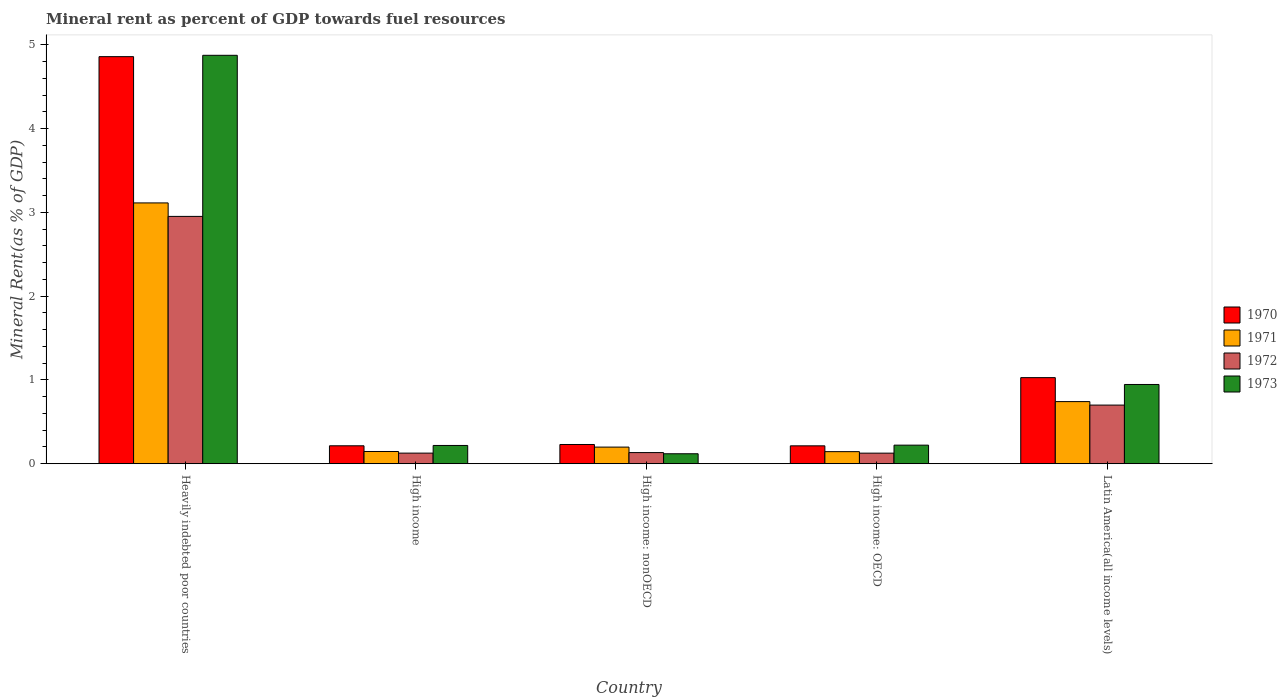How many different coloured bars are there?
Your answer should be compact. 4. What is the label of the 4th group of bars from the left?
Make the answer very short. High income: OECD. What is the mineral rent in 1973 in High income: OECD?
Offer a very short reply. 0.22. Across all countries, what is the maximum mineral rent in 1970?
Your response must be concise. 4.86. Across all countries, what is the minimum mineral rent in 1970?
Offer a terse response. 0.21. In which country was the mineral rent in 1970 maximum?
Ensure brevity in your answer.  Heavily indebted poor countries. In which country was the mineral rent in 1973 minimum?
Your answer should be very brief. High income: nonOECD. What is the total mineral rent in 1970 in the graph?
Your answer should be very brief. 6.54. What is the difference between the mineral rent in 1972 in High income and that in High income: OECD?
Your response must be concise. 0. What is the difference between the mineral rent in 1970 in Latin America(all income levels) and the mineral rent in 1973 in Heavily indebted poor countries?
Make the answer very short. -3.85. What is the average mineral rent in 1970 per country?
Your response must be concise. 1.31. What is the difference between the mineral rent of/in 1972 and mineral rent of/in 1970 in High income?
Your response must be concise. -0.09. In how many countries, is the mineral rent in 1972 greater than 2.2 %?
Your answer should be very brief. 1. What is the ratio of the mineral rent in 1972 in Heavily indebted poor countries to that in High income?
Make the answer very short. 23.3. What is the difference between the highest and the second highest mineral rent in 1973?
Your answer should be compact. -3.93. What is the difference between the highest and the lowest mineral rent in 1972?
Provide a succinct answer. 2.83. Is the sum of the mineral rent in 1971 in High income and High income: nonOECD greater than the maximum mineral rent in 1973 across all countries?
Give a very brief answer. No. Is it the case that in every country, the sum of the mineral rent in 1972 and mineral rent in 1970 is greater than the sum of mineral rent in 1971 and mineral rent in 1973?
Provide a succinct answer. No. What does the 3rd bar from the left in High income: OECD represents?
Give a very brief answer. 1972. What does the 1st bar from the right in Latin America(all income levels) represents?
Provide a succinct answer. 1973. How many bars are there?
Provide a succinct answer. 20. What is the difference between two consecutive major ticks on the Y-axis?
Make the answer very short. 1. Are the values on the major ticks of Y-axis written in scientific E-notation?
Ensure brevity in your answer.  No. Where does the legend appear in the graph?
Offer a terse response. Center right. What is the title of the graph?
Give a very brief answer. Mineral rent as percent of GDP towards fuel resources. Does "1986" appear as one of the legend labels in the graph?
Your answer should be very brief. No. What is the label or title of the X-axis?
Offer a very short reply. Country. What is the label or title of the Y-axis?
Keep it short and to the point. Mineral Rent(as % of GDP). What is the Mineral Rent(as % of GDP) in 1970 in Heavily indebted poor countries?
Provide a short and direct response. 4.86. What is the Mineral Rent(as % of GDP) in 1971 in Heavily indebted poor countries?
Keep it short and to the point. 3.11. What is the Mineral Rent(as % of GDP) of 1972 in Heavily indebted poor countries?
Keep it short and to the point. 2.95. What is the Mineral Rent(as % of GDP) of 1973 in Heavily indebted poor countries?
Offer a terse response. 4.87. What is the Mineral Rent(as % of GDP) of 1970 in High income?
Make the answer very short. 0.21. What is the Mineral Rent(as % of GDP) of 1971 in High income?
Your answer should be compact. 0.15. What is the Mineral Rent(as % of GDP) of 1972 in High income?
Your response must be concise. 0.13. What is the Mineral Rent(as % of GDP) of 1973 in High income?
Make the answer very short. 0.22. What is the Mineral Rent(as % of GDP) of 1970 in High income: nonOECD?
Offer a very short reply. 0.23. What is the Mineral Rent(as % of GDP) in 1971 in High income: nonOECD?
Provide a succinct answer. 0.2. What is the Mineral Rent(as % of GDP) in 1972 in High income: nonOECD?
Make the answer very short. 0.13. What is the Mineral Rent(as % of GDP) in 1973 in High income: nonOECD?
Your response must be concise. 0.12. What is the Mineral Rent(as % of GDP) in 1970 in High income: OECD?
Offer a very short reply. 0.21. What is the Mineral Rent(as % of GDP) of 1971 in High income: OECD?
Your response must be concise. 0.14. What is the Mineral Rent(as % of GDP) of 1972 in High income: OECD?
Keep it short and to the point. 0.13. What is the Mineral Rent(as % of GDP) of 1973 in High income: OECD?
Your response must be concise. 0.22. What is the Mineral Rent(as % of GDP) in 1970 in Latin America(all income levels)?
Your response must be concise. 1.03. What is the Mineral Rent(as % of GDP) of 1971 in Latin America(all income levels)?
Your answer should be compact. 0.74. What is the Mineral Rent(as % of GDP) of 1972 in Latin America(all income levels)?
Your answer should be compact. 0.7. What is the Mineral Rent(as % of GDP) in 1973 in Latin America(all income levels)?
Offer a very short reply. 0.95. Across all countries, what is the maximum Mineral Rent(as % of GDP) in 1970?
Offer a very short reply. 4.86. Across all countries, what is the maximum Mineral Rent(as % of GDP) in 1971?
Give a very brief answer. 3.11. Across all countries, what is the maximum Mineral Rent(as % of GDP) in 1972?
Give a very brief answer. 2.95. Across all countries, what is the maximum Mineral Rent(as % of GDP) of 1973?
Provide a short and direct response. 4.87. Across all countries, what is the minimum Mineral Rent(as % of GDP) of 1970?
Provide a short and direct response. 0.21. Across all countries, what is the minimum Mineral Rent(as % of GDP) of 1971?
Provide a succinct answer. 0.14. Across all countries, what is the minimum Mineral Rent(as % of GDP) in 1972?
Provide a succinct answer. 0.13. Across all countries, what is the minimum Mineral Rent(as % of GDP) in 1973?
Offer a terse response. 0.12. What is the total Mineral Rent(as % of GDP) of 1970 in the graph?
Provide a short and direct response. 6.54. What is the total Mineral Rent(as % of GDP) in 1971 in the graph?
Provide a short and direct response. 4.34. What is the total Mineral Rent(as % of GDP) in 1972 in the graph?
Ensure brevity in your answer.  4.04. What is the total Mineral Rent(as % of GDP) of 1973 in the graph?
Your answer should be compact. 6.38. What is the difference between the Mineral Rent(as % of GDP) in 1970 in Heavily indebted poor countries and that in High income?
Your answer should be compact. 4.64. What is the difference between the Mineral Rent(as % of GDP) in 1971 in Heavily indebted poor countries and that in High income?
Ensure brevity in your answer.  2.97. What is the difference between the Mineral Rent(as % of GDP) in 1972 in Heavily indebted poor countries and that in High income?
Provide a short and direct response. 2.82. What is the difference between the Mineral Rent(as % of GDP) in 1973 in Heavily indebted poor countries and that in High income?
Offer a very short reply. 4.66. What is the difference between the Mineral Rent(as % of GDP) in 1970 in Heavily indebted poor countries and that in High income: nonOECD?
Give a very brief answer. 4.63. What is the difference between the Mineral Rent(as % of GDP) of 1971 in Heavily indebted poor countries and that in High income: nonOECD?
Your response must be concise. 2.91. What is the difference between the Mineral Rent(as % of GDP) of 1972 in Heavily indebted poor countries and that in High income: nonOECD?
Offer a very short reply. 2.82. What is the difference between the Mineral Rent(as % of GDP) of 1973 in Heavily indebted poor countries and that in High income: nonOECD?
Keep it short and to the point. 4.75. What is the difference between the Mineral Rent(as % of GDP) in 1970 in Heavily indebted poor countries and that in High income: OECD?
Offer a very short reply. 4.64. What is the difference between the Mineral Rent(as % of GDP) in 1971 in Heavily indebted poor countries and that in High income: OECD?
Your answer should be very brief. 2.97. What is the difference between the Mineral Rent(as % of GDP) in 1972 in Heavily indebted poor countries and that in High income: OECD?
Make the answer very short. 2.83. What is the difference between the Mineral Rent(as % of GDP) in 1973 in Heavily indebted poor countries and that in High income: OECD?
Ensure brevity in your answer.  4.65. What is the difference between the Mineral Rent(as % of GDP) of 1970 in Heavily indebted poor countries and that in Latin America(all income levels)?
Your answer should be very brief. 3.83. What is the difference between the Mineral Rent(as % of GDP) of 1971 in Heavily indebted poor countries and that in Latin America(all income levels)?
Provide a succinct answer. 2.37. What is the difference between the Mineral Rent(as % of GDP) of 1972 in Heavily indebted poor countries and that in Latin America(all income levels)?
Make the answer very short. 2.25. What is the difference between the Mineral Rent(as % of GDP) in 1973 in Heavily indebted poor countries and that in Latin America(all income levels)?
Your answer should be compact. 3.93. What is the difference between the Mineral Rent(as % of GDP) in 1970 in High income and that in High income: nonOECD?
Ensure brevity in your answer.  -0.02. What is the difference between the Mineral Rent(as % of GDP) of 1971 in High income and that in High income: nonOECD?
Make the answer very short. -0.05. What is the difference between the Mineral Rent(as % of GDP) of 1972 in High income and that in High income: nonOECD?
Make the answer very short. -0.01. What is the difference between the Mineral Rent(as % of GDP) in 1973 in High income and that in High income: nonOECD?
Your answer should be compact. 0.1. What is the difference between the Mineral Rent(as % of GDP) in 1970 in High income and that in High income: OECD?
Provide a succinct answer. 0. What is the difference between the Mineral Rent(as % of GDP) in 1971 in High income and that in High income: OECD?
Give a very brief answer. 0. What is the difference between the Mineral Rent(as % of GDP) in 1972 in High income and that in High income: OECD?
Your answer should be very brief. 0. What is the difference between the Mineral Rent(as % of GDP) in 1973 in High income and that in High income: OECD?
Provide a succinct answer. -0. What is the difference between the Mineral Rent(as % of GDP) of 1970 in High income and that in Latin America(all income levels)?
Keep it short and to the point. -0.81. What is the difference between the Mineral Rent(as % of GDP) in 1971 in High income and that in Latin America(all income levels)?
Provide a short and direct response. -0.6. What is the difference between the Mineral Rent(as % of GDP) of 1972 in High income and that in Latin America(all income levels)?
Make the answer very short. -0.57. What is the difference between the Mineral Rent(as % of GDP) of 1973 in High income and that in Latin America(all income levels)?
Offer a very short reply. -0.73. What is the difference between the Mineral Rent(as % of GDP) in 1970 in High income: nonOECD and that in High income: OECD?
Your answer should be very brief. 0.02. What is the difference between the Mineral Rent(as % of GDP) in 1971 in High income: nonOECD and that in High income: OECD?
Your response must be concise. 0.05. What is the difference between the Mineral Rent(as % of GDP) of 1972 in High income: nonOECD and that in High income: OECD?
Your answer should be compact. 0.01. What is the difference between the Mineral Rent(as % of GDP) of 1973 in High income: nonOECD and that in High income: OECD?
Offer a very short reply. -0.1. What is the difference between the Mineral Rent(as % of GDP) in 1970 in High income: nonOECD and that in Latin America(all income levels)?
Offer a very short reply. -0.8. What is the difference between the Mineral Rent(as % of GDP) in 1971 in High income: nonOECD and that in Latin America(all income levels)?
Keep it short and to the point. -0.54. What is the difference between the Mineral Rent(as % of GDP) of 1972 in High income: nonOECD and that in Latin America(all income levels)?
Make the answer very short. -0.57. What is the difference between the Mineral Rent(as % of GDP) of 1973 in High income: nonOECD and that in Latin America(all income levels)?
Ensure brevity in your answer.  -0.83. What is the difference between the Mineral Rent(as % of GDP) of 1970 in High income: OECD and that in Latin America(all income levels)?
Your answer should be compact. -0.81. What is the difference between the Mineral Rent(as % of GDP) of 1971 in High income: OECD and that in Latin America(all income levels)?
Provide a succinct answer. -0.6. What is the difference between the Mineral Rent(as % of GDP) of 1972 in High income: OECD and that in Latin America(all income levels)?
Provide a short and direct response. -0.57. What is the difference between the Mineral Rent(as % of GDP) of 1973 in High income: OECD and that in Latin America(all income levels)?
Provide a succinct answer. -0.72. What is the difference between the Mineral Rent(as % of GDP) of 1970 in Heavily indebted poor countries and the Mineral Rent(as % of GDP) of 1971 in High income?
Give a very brief answer. 4.71. What is the difference between the Mineral Rent(as % of GDP) of 1970 in Heavily indebted poor countries and the Mineral Rent(as % of GDP) of 1972 in High income?
Your answer should be compact. 4.73. What is the difference between the Mineral Rent(as % of GDP) of 1970 in Heavily indebted poor countries and the Mineral Rent(as % of GDP) of 1973 in High income?
Offer a terse response. 4.64. What is the difference between the Mineral Rent(as % of GDP) in 1971 in Heavily indebted poor countries and the Mineral Rent(as % of GDP) in 1972 in High income?
Ensure brevity in your answer.  2.99. What is the difference between the Mineral Rent(as % of GDP) in 1971 in Heavily indebted poor countries and the Mineral Rent(as % of GDP) in 1973 in High income?
Make the answer very short. 2.89. What is the difference between the Mineral Rent(as % of GDP) in 1972 in Heavily indebted poor countries and the Mineral Rent(as % of GDP) in 1973 in High income?
Offer a terse response. 2.73. What is the difference between the Mineral Rent(as % of GDP) of 1970 in Heavily indebted poor countries and the Mineral Rent(as % of GDP) of 1971 in High income: nonOECD?
Your answer should be very brief. 4.66. What is the difference between the Mineral Rent(as % of GDP) of 1970 in Heavily indebted poor countries and the Mineral Rent(as % of GDP) of 1972 in High income: nonOECD?
Offer a terse response. 4.72. What is the difference between the Mineral Rent(as % of GDP) of 1970 in Heavily indebted poor countries and the Mineral Rent(as % of GDP) of 1973 in High income: nonOECD?
Offer a very short reply. 4.74. What is the difference between the Mineral Rent(as % of GDP) in 1971 in Heavily indebted poor countries and the Mineral Rent(as % of GDP) in 1972 in High income: nonOECD?
Offer a terse response. 2.98. What is the difference between the Mineral Rent(as % of GDP) of 1971 in Heavily indebted poor countries and the Mineral Rent(as % of GDP) of 1973 in High income: nonOECD?
Ensure brevity in your answer.  2.99. What is the difference between the Mineral Rent(as % of GDP) of 1972 in Heavily indebted poor countries and the Mineral Rent(as % of GDP) of 1973 in High income: nonOECD?
Make the answer very short. 2.83. What is the difference between the Mineral Rent(as % of GDP) in 1970 in Heavily indebted poor countries and the Mineral Rent(as % of GDP) in 1971 in High income: OECD?
Offer a terse response. 4.71. What is the difference between the Mineral Rent(as % of GDP) of 1970 in Heavily indebted poor countries and the Mineral Rent(as % of GDP) of 1972 in High income: OECD?
Give a very brief answer. 4.73. What is the difference between the Mineral Rent(as % of GDP) in 1970 in Heavily indebted poor countries and the Mineral Rent(as % of GDP) in 1973 in High income: OECD?
Offer a terse response. 4.64. What is the difference between the Mineral Rent(as % of GDP) in 1971 in Heavily indebted poor countries and the Mineral Rent(as % of GDP) in 1972 in High income: OECD?
Provide a succinct answer. 2.99. What is the difference between the Mineral Rent(as % of GDP) in 1971 in Heavily indebted poor countries and the Mineral Rent(as % of GDP) in 1973 in High income: OECD?
Provide a short and direct response. 2.89. What is the difference between the Mineral Rent(as % of GDP) in 1972 in Heavily indebted poor countries and the Mineral Rent(as % of GDP) in 1973 in High income: OECD?
Offer a terse response. 2.73. What is the difference between the Mineral Rent(as % of GDP) of 1970 in Heavily indebted poor countries and the Mineral Rent(as % of GDP) of 1971 in Latin America(all income levels)?
Offer a very short reply. 4.12. What is the difference between the Mineral Rent(as % of GDP) in 1970 in Heavily indebted poor countries and the Mineral Rent(as % of GDP) in 1972 in Latin America(all income levels)?
Your response must be concise. 4.16. What is the difference between the Mineral Rent(as % of GDP) in 1970 in Heavily indebted poor countries and the Mineral Rent(as % of GDP) in 1973 in Latin America(all income levels)?
Your response must be concise. 3.91. What is the difference between the Mineral Rent(as % of GDP) in 1971 in Heavily indebted poor countries and the Mineral Rent(as % of GDP) in 1972 in Latin America(all income levels)?
Ensure brevity in your answer.  2.41. What is the difference between the Mineral Rent(as % of GDP) in 1971 in Heavily indebted poor countries and the Mineral Rent(as % of GDP) in 1973 in Latin America(all income levels)?
Give a very brief answer. 2.17. What is the difference between the Mineral Rent(as % of GDP) in 1972 in Heavily indebted poor countries and the Mineral Rent(as % of GDP) in 1973 in Latin America(all income levels)?
Provide a short and direct response. 2.01. What is the difference between the Mineral Rent(as % of GDP) of 1970 in High income and the Mineral Rent(as % of GDP) of 1971 in High income: nonOECD?
Keep it short and to the point. 0.02. What is the difference between the Mineral Rent(as % of GDP) of 1970 in High income and the Mineral Rent(as % of GDP) of 1972 in High income: nonOECD?
Your answer should be compact. 0.08. What is the difference between the Mineral Rent(as % of GDP) of 1970 in High income and the Mineral Rent(as % of GDP) of 1973 in High income: nonOECD?
Offer a terse response. 0.1. What is the difference between the Mineral Rent(as % of GDP) of 1971 in High income and the Mineral Rent(as % of GDP) of 1972 in High income: nonOECD?
Ensure brevity in your answer.  0.01. What is the difference between the Mineral Rent(as % of GDP) of 1971 in High income and the Mineral Rent(as % of GDP) of 1973 in High income: nonOECD?
Your answer should be compact. 0.03. What is the difference between the Mineral Rent(as % of GDP) of 1972 in High income and the Mineral Rent(as % of GDP) of 1973 in High income: nonOECD?
Provide a short and direct response. 0.01. What is the difference between the Mineral Rent(as % of GDP) of 1970 in High income and the Mineral Rent(as % of GDP) of 1971 in High income: OECD?
Offer a terse response. 0.07. What is the difference between the Mineral Rent(as % of GDP) in 1970 in High income and the Mineral Rent(as % of GDP) in 1972 in High income: OECD?
Ensure brevity in your answer.  0.09. What is the difference between the Mineral Rent(as % of GDP) of 1970 in High income and the Mineral Rent(as % of GDP) of 1973 in High income: OECD?
Your response must be concise. -0.01. What is the difference between the Mineral Rent(as % of GDP) in 1971 in High income and the Mineral Rent(as % of GDP) in 1972 in High income: OECD?
Ensure brevity in your answer.  0.02. What is the difference between the Mineral Rent(as % of GDP) of 1971 in High income and the Mineral Rent(as % of GDP) of 1973 in High income: OECD?
Provide a succinct answer. -0.08. What is the difference between the Mineral Rent(as % of GDP) in 1972 in High income and the Mineral Rent(as % of GDP) in 1973 in High income: OECD?
Your answer should be very brief. -0.1. What is the difference between the Mineral Rent(as % of GDP) in 1970 in High income and the Mineral Rent(as % of GDP) in 1971 in Latin America(all income levels)?
Keep it short and to the point. -0.53. What is the difference between the Mineral Rent(as % of GDP) of 1970 in High income and the Mineral Rent(as % of GDP) of 1972 in Latin America(all income levels)?
Your response must be concise. -0.49. What is the difference between the Mineral Rent(as % of GDP) of 1970 in High income and the Mineral Rent(as % of GDP) of 1973 in Latin America(all income levels)?
Keep it short and to the point. -0.73. What is the difference between the Mineral Rent(as % of GDP) of 1971 in High income and the Mineral Rent(as % of GDP) of 1972 in Latin America(all income levels)?
Offer a very short reply. -0.55. What is the difference between the Mineral Rent(as % of GDP) of 1971 in High income and the Mineral Rent(as % of GDP) of 1973 in Latin America(all income levels)?
Ensure brevity in your answer.  -0.8. What is the difference between the Mineral Rent(as % of GDP) of 1972 in High income and the Mineral Rent(as % of GDP) of 1973 in Latin America(all income levels)?
Give a very brief answer. -0.82. What is the difference between the Mineral Rent(as % of GDP) of 1970 in High income: nonOECD and the Mineral Rent(as % of GDP) of 1971 in High income: OECD?
Ensure brevity in your answer.  0.09. What is the difference between the Mineral Rent(as % of GDP) of 1970 in High income: nonOECD and the Mineral Rent(as % of GDP) of 1972 in High income: OECD?
Give a very brief answer. 0.1. What is the difference between the Mineral Rent(as % of GDP) of 1970 in High income: nonOECD and the Mineral Rent(as % of GDP) of 1973 in High income: OECD?
Provide a short and direct response. 0.01. What is the difference between the Mineral Rent(as % of GDP) of 1971 in High income: nonOECD and the Mineral Rent(as % of GDP) of 1972 in High income: OECD?
Ensure brevity in your answer.  0.07. What is the difference between the Mineral Rent(as % of GDP) in 1971 in High income: nonOECD and the Mineral Rent(as % of GDP) in 1973 in High income: OECD?
Your answer should be very brief. -0.02. What is the difference between the Mineral Rent(as % of GDP) in 1972 in High income: nonOECD and the Mineral Rent(as % of GDP) in 1973 in High income: OECD?
Ensure brevity in your answer.  -0.09. What is the difference between the Mineral Rent(as % of GDP) of 1970 in High income: nonOECD and the Mineral Rent(as % of GDP) of 1971 in Latin America(all income levels)?
Keep it short and to the point. -0.51. What is the difference between the Mineral Rent(as % of GDP) in 1970 in High income: nonOECD and the Mineral Rent(as % of GDP) in 1972 in Latin America(all income levels)?
Make the answer very short. -0.47. What is the difference between the Mineral Rent(as % of GDP) in 1970 in High income: nonOECD and the Mineral Rent(as % of GDP) in 1973 in Latin America(all income levels)?
Ensure brevity in your answer.  -0.72. What is the difference between the Mineral Rent(as % of GDP) of 1971 in High income: nonOECD and the Mineral Rent(as % of GDP) of 1972 in Latin America(all income levels)?
Your answer should be very brief. -0.5. What is the difference between the Mineral Rent(as % of GDP) of 1971 in High income: nonOECD and the Mineral Rent(as % of GDP) of 1973 in Latin America(all income levels)?
Your answer should be very brief. -0.75. What is the difference between the Mineral Rent(as % of GDP) in 1972 in High income: nonOECD and the Mineral Rent(as % of GDP) in 1973 in Latin America(all income levels)?
Your answer should be compact. -0.81. What is the difference between the Mineral Rent(as % of GDP) of 1970 in High income: OECD and the Mineral Rent(as % of GDP) of 1971 in Latin America(all income levels)?
Provide a short and direct response. -0.53. What is the difference between the Mineral Rent(as % of GDP) of 1970 in High income: OECD and the Mineral Rent(as % of GDP) of 1972 in Latin America(all income levels)?
Provide a succinct answer. -0.49. What is the difference between the Mineral Rent(as % of GDP) of 1970 in High income: OECD and the Mineral Rent(as % of GDP) of 1973 in Latin America(all income levels)?
Make the answer very short. -0.73. What is the difference between the Mineral Rent(as % of GDP) of 1971 in High income: OECD and the Mineral Rent(as % of GDP) of 1972 in Latin America(all income levels)?
Give a very brief answer. -0.56. What is the difference between the Mineral Rent(as % of GDP) in 1971 in High income: OECD and the Mineral Rent(as % of GDP) in 1973 in Latin America(all income levels)?
Offer a very short reply. -0.8. What is the difference between the Mineral Rent(as % of GDP) in 1972 in High income: OECD and the Mineral Rent(as % of GDP) in 1973 in Latin America(all income levels)?
Offer a terse response. -0.82. What is the average Mineral Rent(as % of GDP) in 1970 per country?
Give a very brief answer. 1.31. What is the average Mineral Rent(as % of GDP) in 1971 per country?
Keep it short and to the point. 0.87. What is the average Mineral Rent(as % of GDP) in 1972 per country?
Provide a short and direct response. 0.81. What is the average Mineral Rent(as % of GDP) in 1973 per country?
Give a very brief answer. 1.28. What is the difference between the Mineral Rent(as % of GDP) of 1970 and Mineral Rent(as % of GDP) of 1971 in Heavily indebted poor countries?
Give a very brief answer. 1.75. What is the difference between the Mineral Rent(as % of GDP) of 1970 and Mineral Rent(as % of GDP) of 1972 in Heavily indebted poor countries?
Keep it short and to the point. 1.91. What is the difference between the Mineral Rent(as % of GDP) in 1970 and Mineral Rent(as % of GDP) in 1973 in Heavily indebted poor countries?
Offer a terse response. -0.02. What is the difference between the Mineral Rent(as % of GDP) of 1971 and Mineral Rent(as % of GDP) of 1972 in Heavily indebted poor countries?
Give a very brief answer. 0.16. What is the difference between the Mineral Rent(as % of GDP) in 1971 and Mineral Rent(as % of GDP) in 1973 in Heavily indebted poor countries?
Provide a short and direct response. -1.76. What is the difference between the Mineral Rent(as % of GDP) of 1972 and Mineral Rent(as % of GDP) of 1973 in Heavily indebted poor countries?
Provide a succinct answer. -1.92. What is the difference between the Mineral Rent(as % of GDP) in 1970 and Mineral Rent(as % of GDP) in 1971 in High income?
Provide a short and direct response. 0.07. What is the difference between the Mineral Rent(as % of GDP) in 1970 and Mineral Rent(as % of GDP) in 1972 in High income?
Your answer should be very brief. 0.09. What is the difference between the Mineral Rent(as % of GDP) in 1970 and Mineral Rent(as % of GDP) in 1973 in High income?
Offer a very short reply. -0. What is the difference between the Mineral Rent(as % of GDP) of 1971 and Mineral Rent(as % of GDP) of 1972 in High income?
Your answer should be compact. 0.02. What is the difference between the Mineral Rent(as % of GDP) of 1971 and Mineral Rent(as % of GDP) of 1973 in High income?
Offer a very short reply. -0.07. What is the difference between the Mineral Rent(as % of GDP) in 1972 and Mineral Rent(as % of GDP) in 1973 in High income?
Offer a terse response. -0.09. What is the difference between the Mineral Rent(as % of GDP) in 1970 and Mineral Rent(as % of GDP) in 1971 in High income: nonOECD?
Make the answer very short. 0.03. What is the difference between the Mineral Rent(as % of GDP) in 1970 and Mineral Rent(as % of GDP) in 1972 in High income: nonOECD?
Ensure brevity in your answer.  0.1. What is the difference between the Mineral Rent(as % of GDP) in 1970 and Mineral Rent(as % of GDP) in 1973 in High income: nonOECD?
Offer a terse response. 0.11. What is the difference between the Mineral Rent(as % of GDP) of 1971 and Mineral Rent(as % of GDP) of 1972 in High income: nonOECD?
Provide a succinct answer. 0.07. What is the difference between the Mineral Rent(as % of GDP) in 1971 and Mineral Rent(as % of GDP) in 1973 in High income: nonOECD?
Your response must be concise. 0.08. What is the difference between the Mineral Rent(as % of GDP) in 1972 and Mineral Rent(as % of GDP) in 1973 in High income: nonOECD?
Keep it short and to the point. 0.01. What is the difference between the Mineral Rent(as % of GDP) in 1970 and Mineral Rent(as % of GDP) in 1971 in High income: OECD?
Provide a succinct answer. 0.07. What is the difference between the Mineral Rent(as % of GDP) in 1970 and Mineral Rent(as % of GDP) in 1972 in High income: OECD?
Provide a succinct answer. 0.09. What is the difference between the Mineral Rent(as % of GDP) in 1970 and Mineral Rent(as % of GDP) in 1973 in High income: OECD?
Your answer should be very brief. -0.01. What is the difference between the Mineral Rent(as % of GDP) of 1971 and Mineral Rent(as % of GDP) of 1972 in High income: OECD?
Make the answer very short. 0.02. What is the difference between the Mineral Rent(as % of GDP) of 1971 and Mineral Rent(as % of GDP) of 1973 in High income: OECD?
Ensure brevity in your answer.  -0.08. What is the difference between the Mineral Rent(as % of GDP) of 1972 and Mineral Rent(as % of GDP) of 1973 in High income: OECD?
Offer a very short reply. -0.1. What is the difference between the Mineral Rent(as % of GDP) in 1970 and Mineral Rent(as % of GDP) in 1971 in Latin America(all income levels)?
Keep it short and to the point. 0.29. What is the difference between the Mineral Rent(as % of GDP) of 1970 and Mineral Rent(as % of GDP) of 1972 in Latin America(all income levels)?
Offer a terse response. 0.33. What is the difference between the Mineral Rent(as % of GDP) in 1970 and Mineral Rent(as % of GDP) in 1973 in Latin America(all income levels)?
Your answer should be compact. 0.08. What is the difference between the Mineral Rent(as % of GDP) in 1971 and Mineral Rent(as % of GDP) in 1972 in Latin America(all income levels)?
Your response must be concise. 0.04. What is the difference between the Mineral Rent(as % of GDP) of 1971 and Mineral Rent(as % of GDP) of 1973 in Latin America(all income levels)?
Offer a very short reply. -0.2. What is the difference between the Mineral Rent(as % of GDP) of 1972 and Mineral Rent(as % of GDP) of 1973 in Latin America(all income levels)?
Make the answer very short. -0.25. What is the ratio of the Mineral Rent(as % of GDP) of 1970 in Heavily indebted poor countries to that in High income?
Your answer should be compact. 22.69. What is the ratio of the Mineral Rent(as % of GDP) in 1971 in Heavily indebted poor countries to that in High income?
Make the answer very short. 21.31. What is the ratio of the Mineral Rent(as % of GDP) of 1972 in Heavily indebted poor countries to that in High income?
Make the answer very short. 23.3. What is the ratio of the Mineral Rent(as % of GDP) of 1973 in Heavily indebted poor countries to that in High income?
Provide a succinct answer. 22.35. What is the ratio of the Mineral Rent(as % of GDP) of 1970 in Heavily indebted poor countries to that in High income: nonOECD?
Offer a terse response. 21.14. What is the ratio of the Mineral Rent(as % of GDP) of 1971 in Heavily indebted poor countries to that in High income: nonOECD?
Give a very brief answer. 15.68. What is the ratio of the Mineral Rent(as % of GDP) of 1972 in Heavily indebted poor countries to that in High income: nonOECD?
Keep it short and to the point. 22.17. What is the ratio of the Mineral Rent(as % of GDP) of 1973 in Heavily indebted poor countries to that in High income: nonOECD?
Offer a terse response. 40.95. What is the ratio of the Mineral Rent(as % of GDP) in 1970 in Heavily indebted poor countries to that in High income: OECD?
Offer a terse response. 22.74. What is the ratio of the Mineral Rent(as % of GDP) of 1971 in Heavily indebted poor countries to that in High income: OECD?
Make the answer very short. 21.57. What is the ratio of the Mineral Rent(as % of GDP) of 1972 in Heavily indebted poor countries to that in High income: OECD?
Offer a very short reply. 23.34. What is the ratio of the Mineral Rent(as % of GDP) of 1973 in Heavily indebted poor countries to that in High income: OECD?
Offer a terse response. 21.98. What is the ratio of the Mineral Rent(as % of GDP) of 1970 in Heavily indebted poor countries to that in Latin America(all income levels)?
Your response must be concise. 4.73. What is the ratio of the Mineral Rent(as % of GDP) in 1971 in Heavily indebted poor countries to that in Latin America(all income levels)?
Give a very brief answer. 4.2. What is the ratio of the Mineral Rent(as % of GDP) in 1972 in Heavily indebted poor countries to that in Latin America(all income levels)?
Your answer should be very brief. 4.22. What is the ratio of the Mineral Rent(as % of GDP) in 1973 in Heavily indebted poor countries to that in Latin America(all income levels)?
Ensure brevity in your answer.  5.15. What is the ratio of the Mineral Rent(as % of GDP) in 1970 in High income to that in High income: nonOECD?
Provide a short and direct response. 0.93. What is the ratio of the Mineral Rent(as % of GDP) of 1971 in High income to that in High income: nonOECD?
Offer a terse response. 0.74. What is the ratio of the Mineral Rent(as % of GDP) of 1972 in High income to that in High income: nonOECD?
Give a very brief answer. 0.95. What is the ratio of the Mineral Rent(as % of GDP) in 1973 in High income to that in High income: nonOECD?
Provide a short and direct response. 1.83. What is the ratio of the Mineral Rent(as % of GDP) in 1970 in High income to that in High income: OECD?
Offer a very short reply. 1. What is the ratio of the Mineral Rent(as % of GDP) of 1971 in High income to that in High income: OECD?
Provide a succinct answer. 1.01. What is the ratio of the Mineral Rent(as % of GDP) in 1972 in High income to that in High income: OECD?
Your answer should be very brief. 1. What is the ratio of the Mineral Rent(as % of GDP) in 1973 in High income to that in High income: OECD?
Keep it short and to the point. 0.98. What is the ratio of the Mineral Rent(as % of GDP) of 1970 in High income to that in Latin America(all income levels)?
Offer a terse response. 0.21. What is the ratio of the Mineral Rent(as % of GDP) in 1971 in High income to that in Latin America(all income levels)?
Give a very brief answer. 0.2. What is the ratio of the Mineral Rent(as % of GDP) of 1972 in High income to that in Latin America(all income levels)?
Offer a very short reply. 0.18. What is the ratio of the Mineral Rent(as % of GDP) in 1973 in High income to that in Latin America(all income levels)?
Provide a short and direct response. 0.23. What is the ratio of the Mineral Rent(as % of GDP) of 1970 in High income: nonOECD to that in High income: OECD?
Give a very brief answer. 1.08. What is the ratio of the Mineral Rent(as % of GDP) in 1971 in High income: nonOECD to that in High income: OECD?
Provide a succinct answer. 1.38. What is the ratio of the Mineral Rent(as % of GDP) in 1972 in High income: nonOECD to that in High income: OECD?
Ensure brevity in your answer.  1.05. What is the ratio of the Mineral Rent(as % of GDP) in 1973 in High income: nonOECD to that in High income: OECD?
Make the answer very short. 0.54. What is the ratio of the Mineral Rent(as % of GDP) in 1970 in High income: nonOECD to that in Latin America(all income levels)?
Offer a very short reply. 0.22. What is the ratio of the Mineral Rent(as % of GDP) in 1971 in High income: nonOECD to that in Latin America(all income levels)?
Your response must be concise. 0.27. What is the ratio of the Mineral Rent(as % of GDP) in 1972 in High income: nonOECD to that in Latin America(all income levels)?
Make the answer very short. 0.19. What is the ratio of the Mineral Rent(as % of GDP) of 1973 in High income: nonOECD to that in Latin America(all income levels)?
Keep it short and to the point. 0.13. What is the ratio of the Mineral Rent(as % of GDP) in 1970 in High income: OECD to that in Latin America(all income levels)?
Offer a terse response. 0.21. What is the ratio of the Mineral Rent(as % of GDP) in 1971 in High income: OECD to that in Latin America(all income levels)?
Your answer should be compact. 0.19. What is the ratio of the Mineral Rent(as % of GDP) of 1972 in High income: OECD to that in Latin America(all income levels)?
Offer a terse response. 0.18. What is the ratio of the Mineral Rent(as % of GDP) in 1973 in High income: OECD to that in Latin America(all income levels)?
Give a very brief answer. 0.23. What is the difference between the highest and the second highest Mineral Rent(as % of GDP) of 1970?
Your response must be concise. 3.83. What is the difference between the highest and the second highest Mineral Rent(as % of GDP) in 1971?
Provide a short and direct response. 2.37. What is the difference between the highest and the second highest Mineral Rent(as % of GDP) of 1972?
Ensure brevity in your answer.  2.25. What is the difference between the highest and the second highest Mineral Rent(as % of GDP) in 1973?
Your answer should be compact. 3.93. What is the difference between the highest and the lowest Mineral Rent(as % of GDP) in 1970?
Give a very brief answer. 4.64. What is the difference between the highest and the lowest Mineral Rent(as % of GDP) in 1971?
Offer a terse response. 2.97. What is the difference between the highest and the lowest Mineral Rent(as % of GDP) in 1972?
Offer a terse response. 2.83. What is the difference between the highest and the lowest Mineral Rent(as % of GDP) of 1973?
Your answer should be very brief. 4.75. 